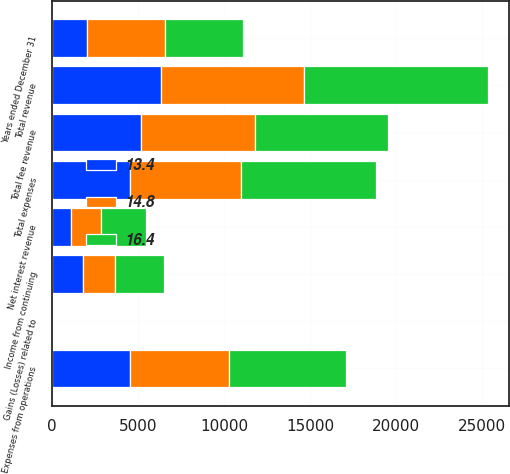Convert chart to OTSL. <chart><loc_0><loc_0><loc_500><loc_500><stacked_bar_chart><ecel><fcel>Years ended December 31<fcel>Total fee revenue<fcel>Net interest revenue<fcel>Gains (Losses) related to<fcel>Total revenue<fcel>Expenses from operations<fcel>Total expenses<fcel>Income from continuing<nl><fcel>16.4<fcel>4540<fcel>7747<fcel>2650<fcel>54<fcel>10693<fcel>6780<fcel>7851<fcel>2842<nl><fcel>14.8<fcel>4540<fcel>6633<fcel>1730<fcel>27<fcel>8336<fcel>5768<fcel>6433<fcel>1903<nl><fcel>13.4<fcel>2006<fcel>5186<fcel>1110<fcel>15<fcel>6311<fcel>4540<fcel>4540<fcel>1771<nl></chart> 